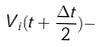<formula> <loc_0><loc_0><loc_500><loc_500>V _ { i } ( t + \frac { \Delta t } { 2 } ) -</formula> 